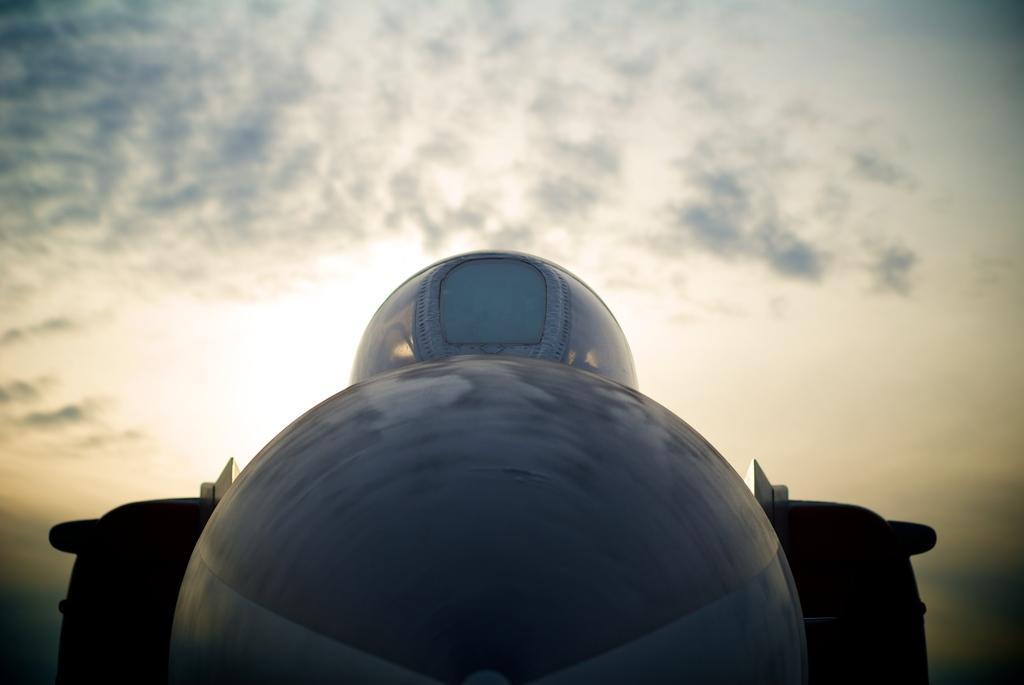How would you summarize this image in a sentence or two? In the foreground of this picture we can see an object seems to be the vehicle. In the background we can see the sky which is full of clouds. 